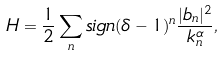<formula> <loc_0><loc_0><loc_500><loc_500>H = \frac { 1 } { 2 } \sum _ { n } s i g n ( \delta - 1 ) ^ { n } \frac { | b _ { n } | ^ { 2 } } { k _ { n } ^ { \alpha } } ,</formula> 